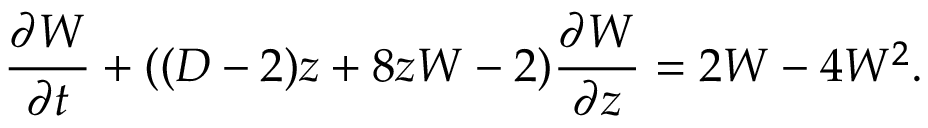Convert formula to latex. <formula><loc_0><loc_0><loc_500><loc_500>\frac { \partial W } { \partial t } + ( ( D - 2 ) z + 8 z W - 2 ) \frac { \partial W } { \partial z } = 2 W - 4 W ^ { 2 } .</formula> 